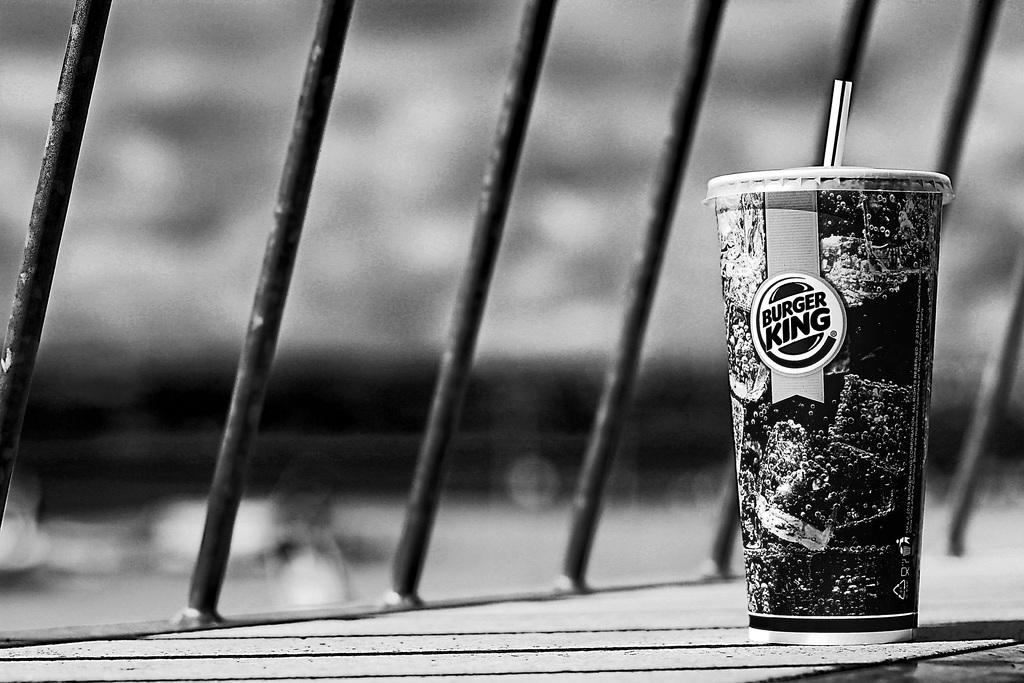How would you summarize this image in a sentence or two? This is a black and white image. In this image we can see a glass with a straw which is placed on the surface. We can also see some metal rods beside it. 